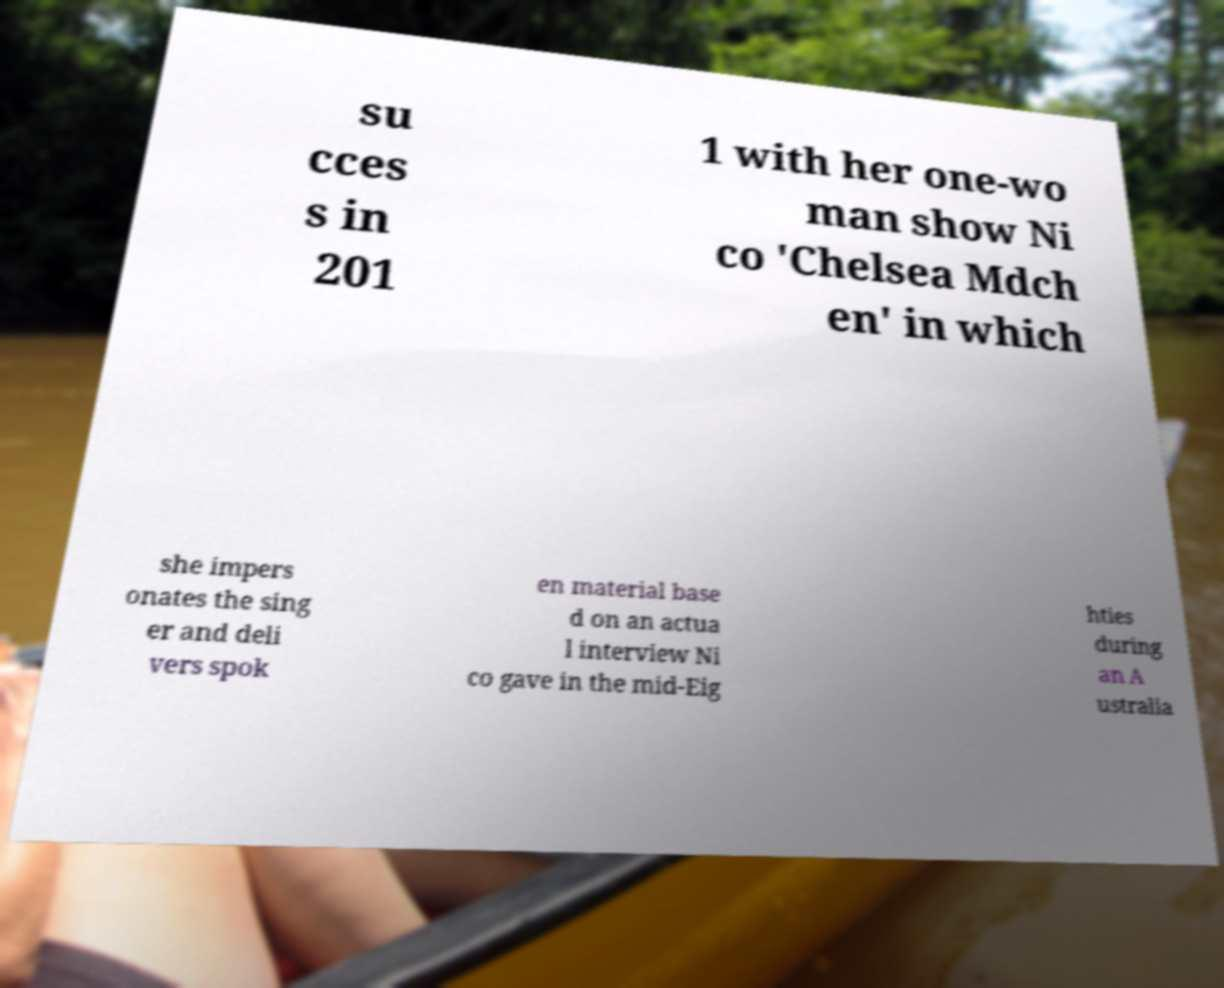Could you assist in decoding the text presented in this image and type it out clearly? su cces s in 201 1 with her one-wo man show Ni co 'Chelsea Mdch en' in which she impers onates the sing er and deli vers spok en material base d on an actua l interview Ni co gave in the mid-Eig hties during an A ustralia 